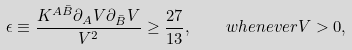Convert formula to latex. <formula><loc_0><loc_0><loc_500><loc_500>\epsilon \equiv \frac { K ^ { A \bar { B } } \partial _ { A } V \partial _ { \bar { B } } V } { V ^ { 2 } } \geq \frac { 2 7 } { 1 3 } , \quad w h e n e v e r V > 0 ,</formula> 